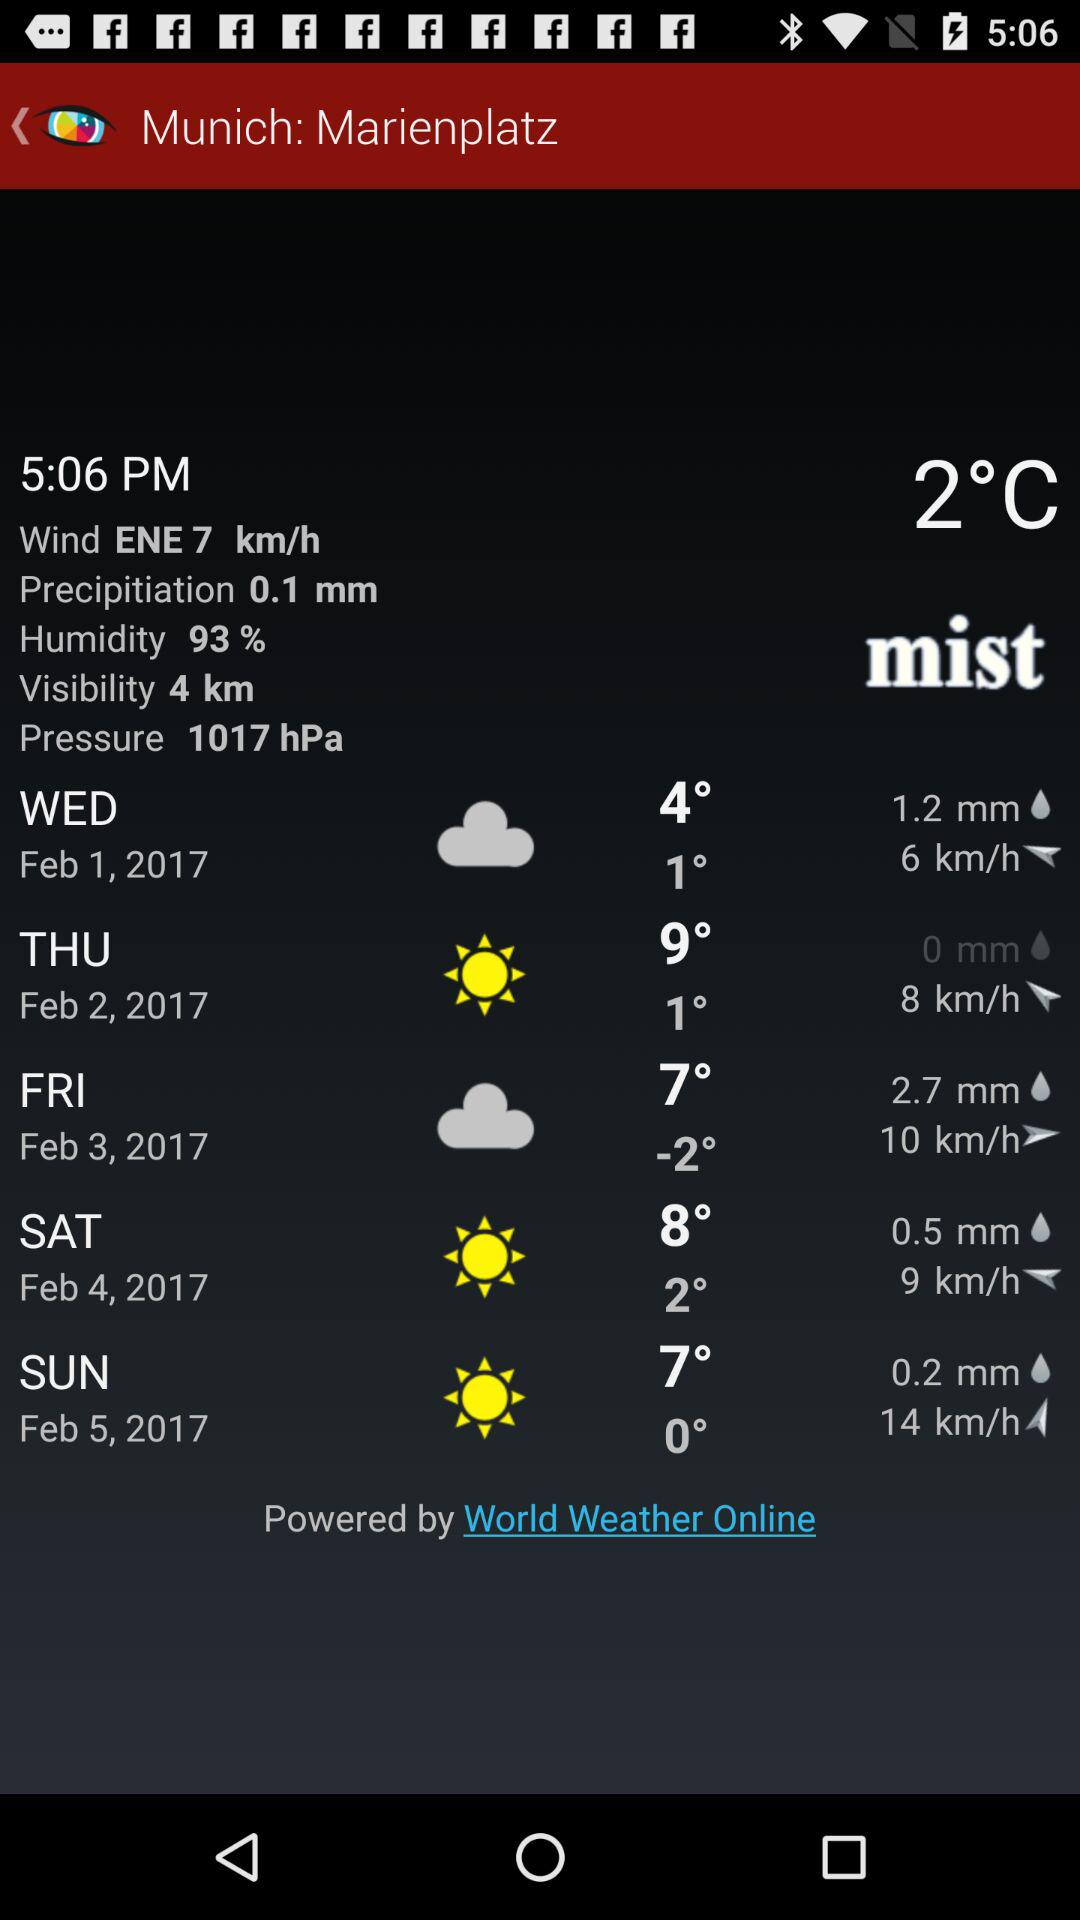What is the given time? The given time is 5:06 p.m. 